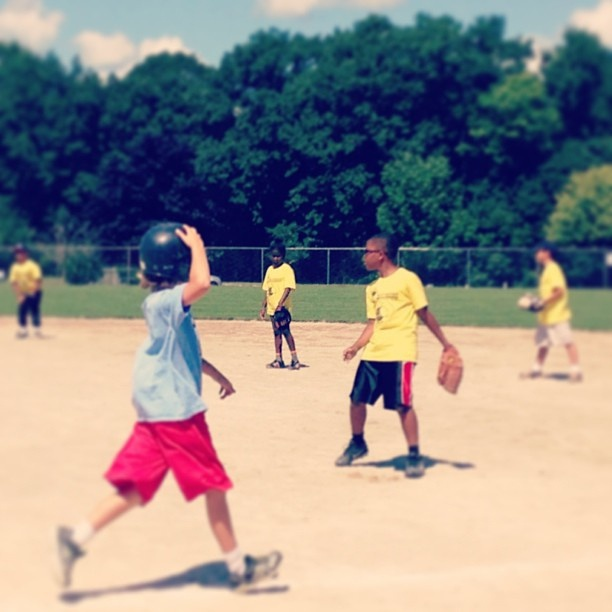Describe the objects in this image and their specific colors. I can see people in lightblue, brown, lightgray, tan, and lightpink tones, people in lightblue, khaki, navy, and brown tones, people in lightblue, tan, and darkgray tones, people in lightblue, khaki, navy, purple, and gray tones, and people in lightblue, navy, gray, and tan tones in this image. 